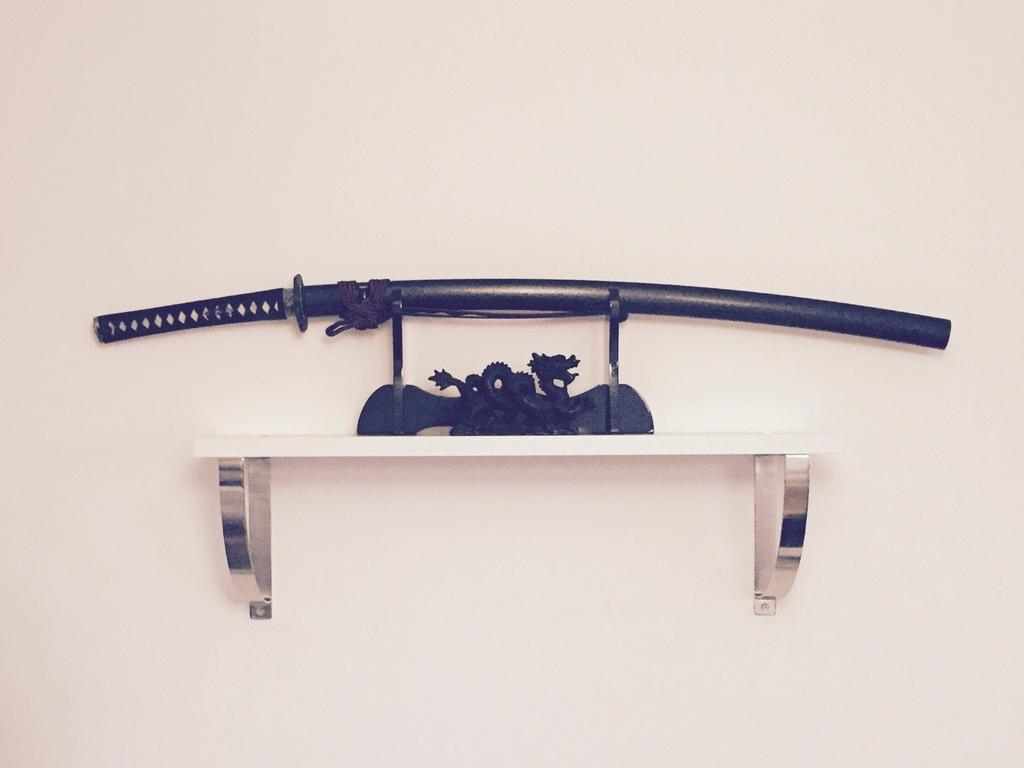What color is the wall in the image? The wall in the image is cream-colored. What piece of furniture is present in the image? There is a desk in the image. What object is on the desk, and what color is it? There is a black-colored sword stand on the desk. What item is on the sword stand, and what color is it? There is a black sword on the sword stand. What type of berry can be seen growing on the wall in the image? There are no berries present in the image; it features a cream-colored wall, a desk, a black sword stand, and a black sword. 